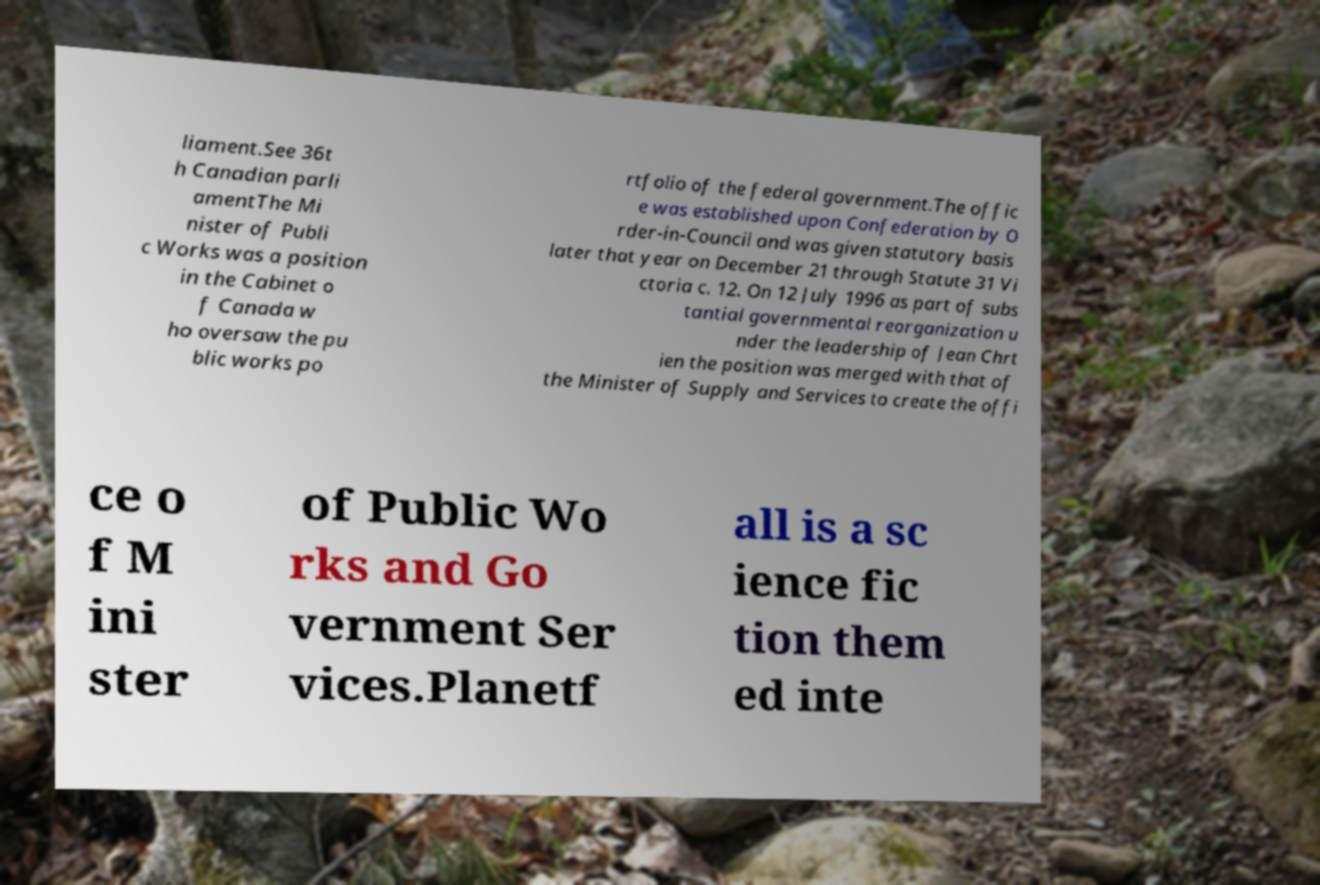Could you extract and type out the text from this image? liament.See 36t h Canadian parli amentThe Mi nister of Publi c Works was a position in the Cabinet o f Canada w ho oversaw the pu blic works po rtfolio of the federal government.The offic e was established upon Confederation by O rder-in-Council and was given statutory basis later that year on December 21 through Statute 31 Vi ctoria c. 12. On 12 July 1996 as part of subs tantial governmental reorganization u nder the leadership of Jean Chrt ien the position was merged with that of the Minister of Supply and Services to create the offi ce o f M ini ster of Public Wo rks and Go vernment Ser vices.Planetf all is a sc ience fic tion them ed inte 